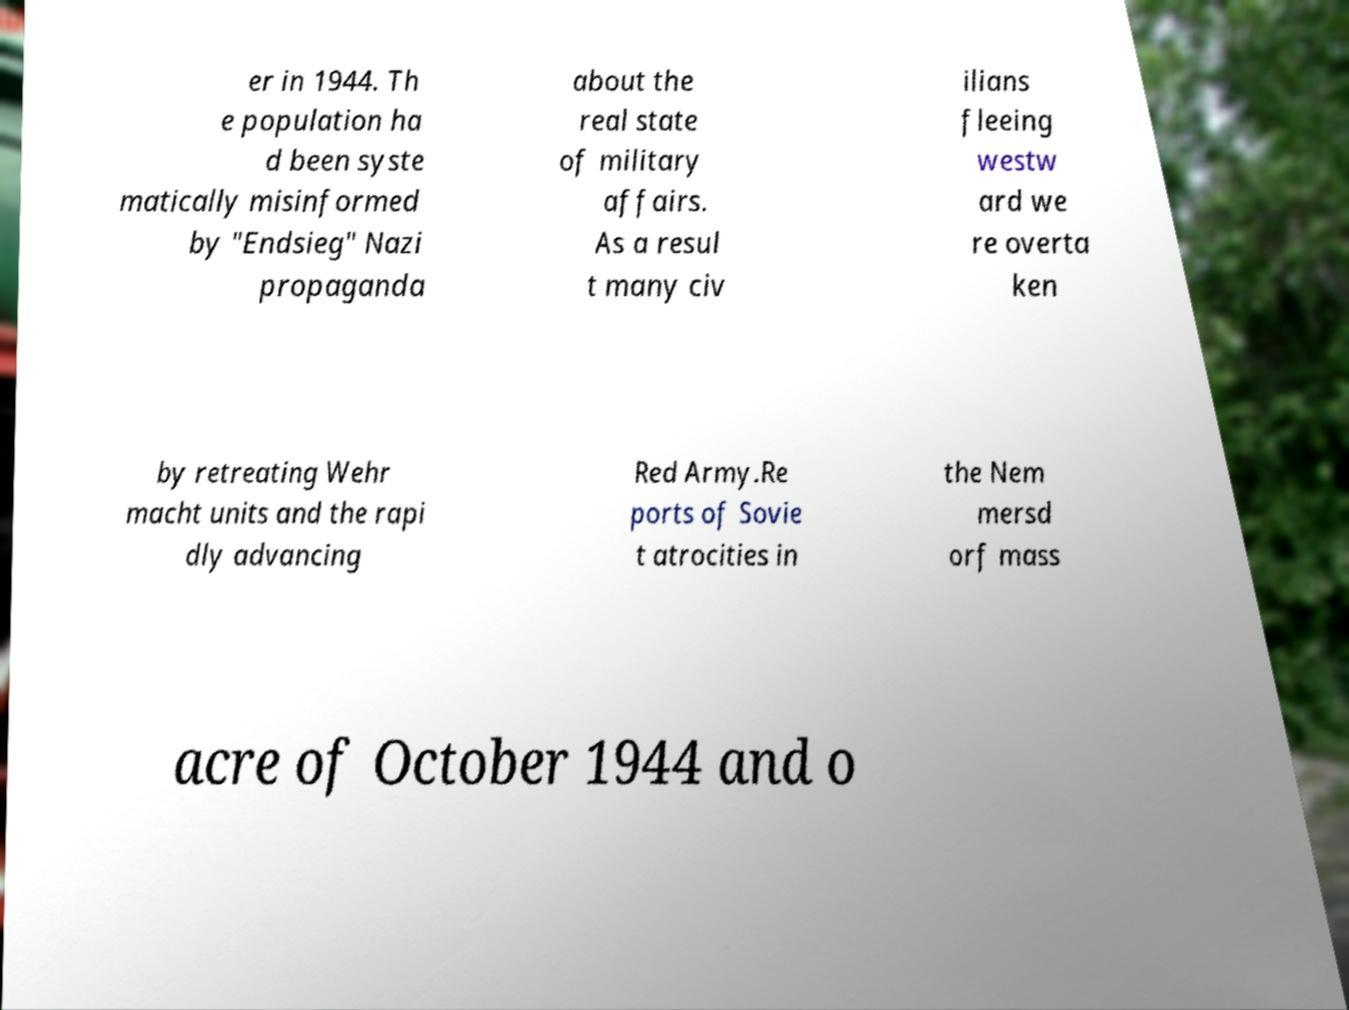What messages or text are displayed in this image? I need them in a readable, typed format. er in 1944. Th e population ha d been syste matically misinformed by "Endsieg" Nazi propaganda about the real state of military affairs. As a resul t many civ ilians fleeing westw ard we re overta ken by retreating Wehr macht units and the rapi dly advancing Red Army.Re ports of Sovie t atrocities in the Nem mersd orf mass acre of October 1944 and o 